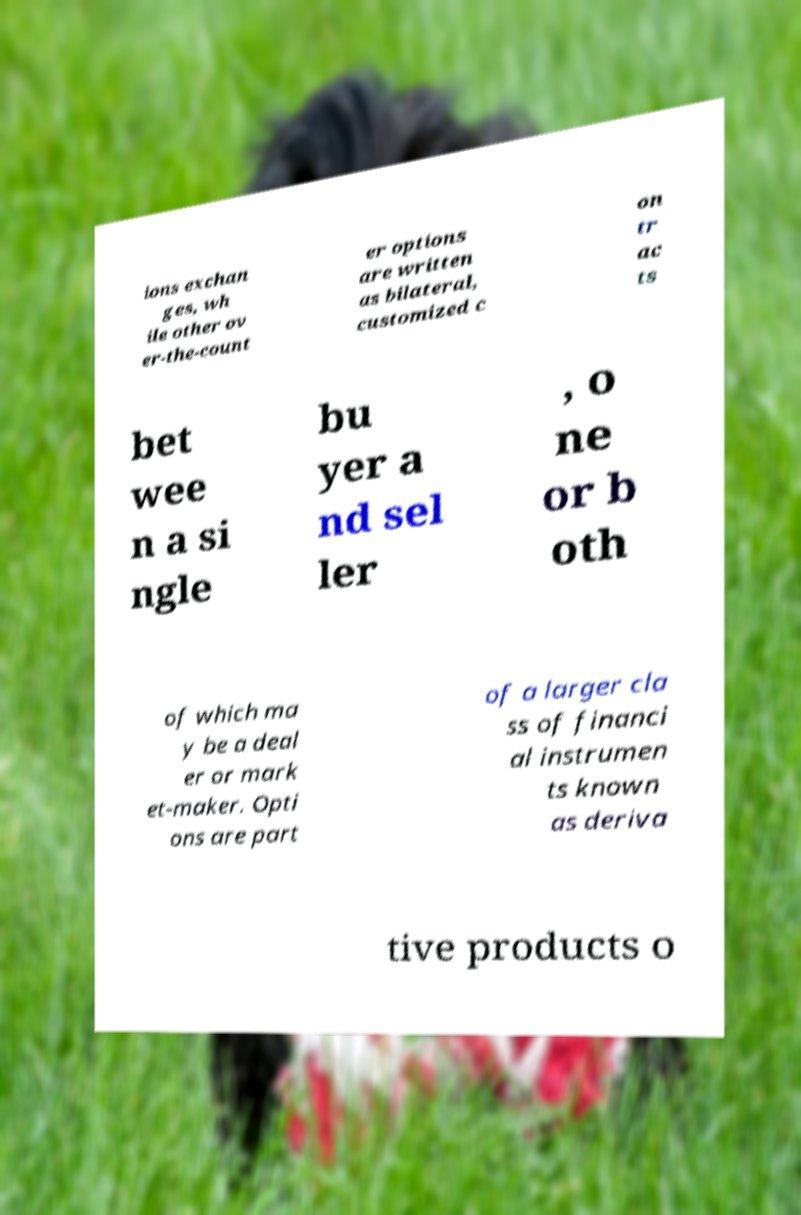Could you extract and type out the text from this image? ions exchan ges, wh ile other ov er-the-count er options are written as bilateral, customized c on tr ac ts bet wee n a si ngle bu yer a nd sel ler , o ne or b oth of which ma y be a deal er or mark et-maker. Opti ons are part of a larger cla ss of financi al instrumen ts known as deriva tive products o 